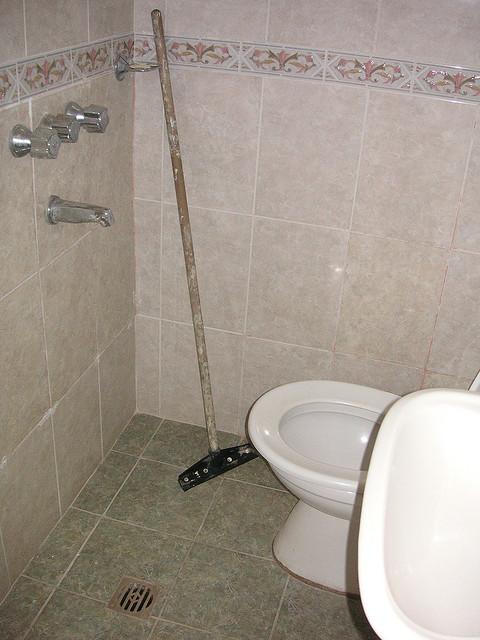What color is the tile on the floor?
Be succinct. Gray. Is this a large bathroom?
Give a very brief answer. No. What can be used to clean the toilet?
Keep it brief. Brush. What kind of flooring is pictured?
Write a very short answer. Tile. 